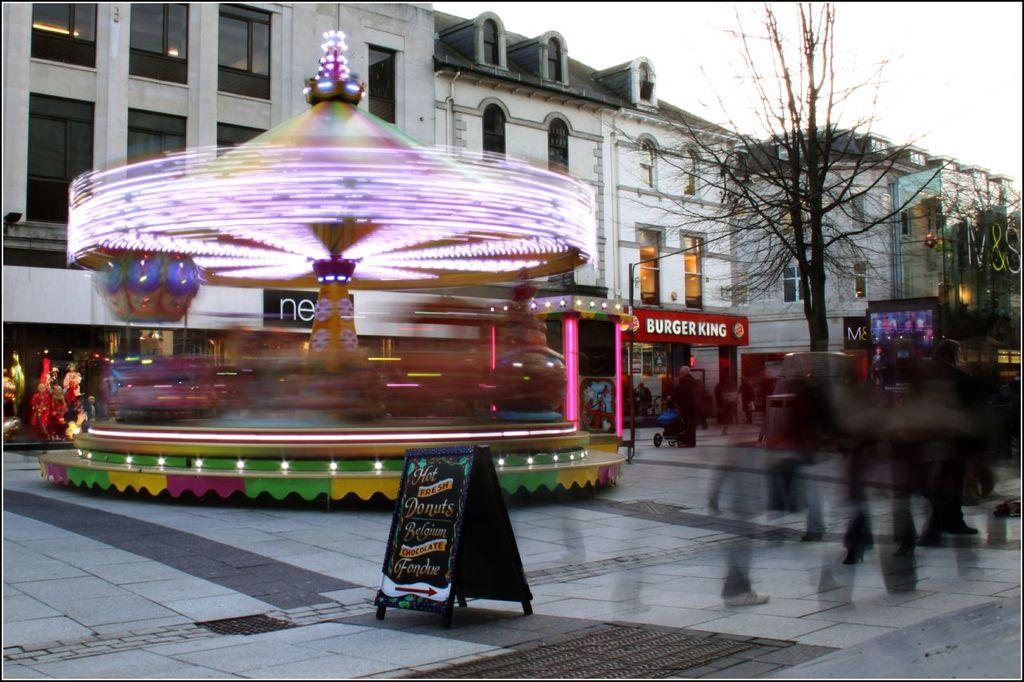<image>
Create a compact narrative representing the image presented. People walking in an area with a Burger King in the back. 